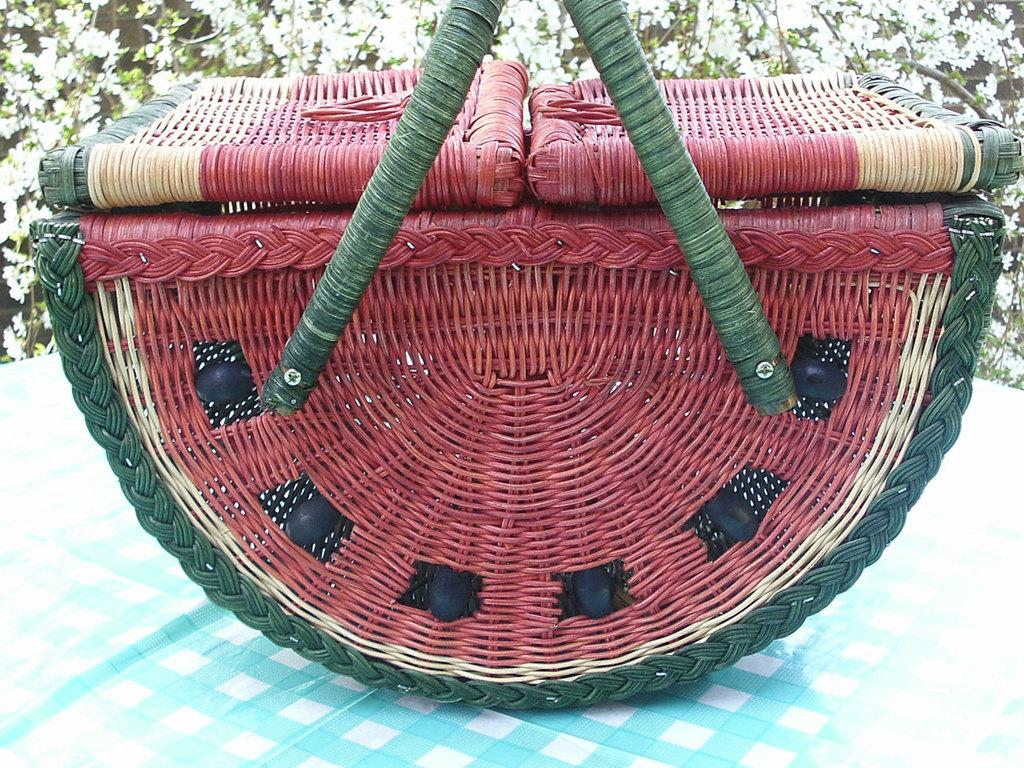What object is present in the image? There is a basket in the image. On what surface is the basket placed? The basket is on a white and blue color cloth. What can be seen in the background of the image? There are white flowers in the background of the image. What error occurred while taking the picture of the basket? There is no indication of any error in the image; it appears to be a clear and well-composed photograph of the basket. 